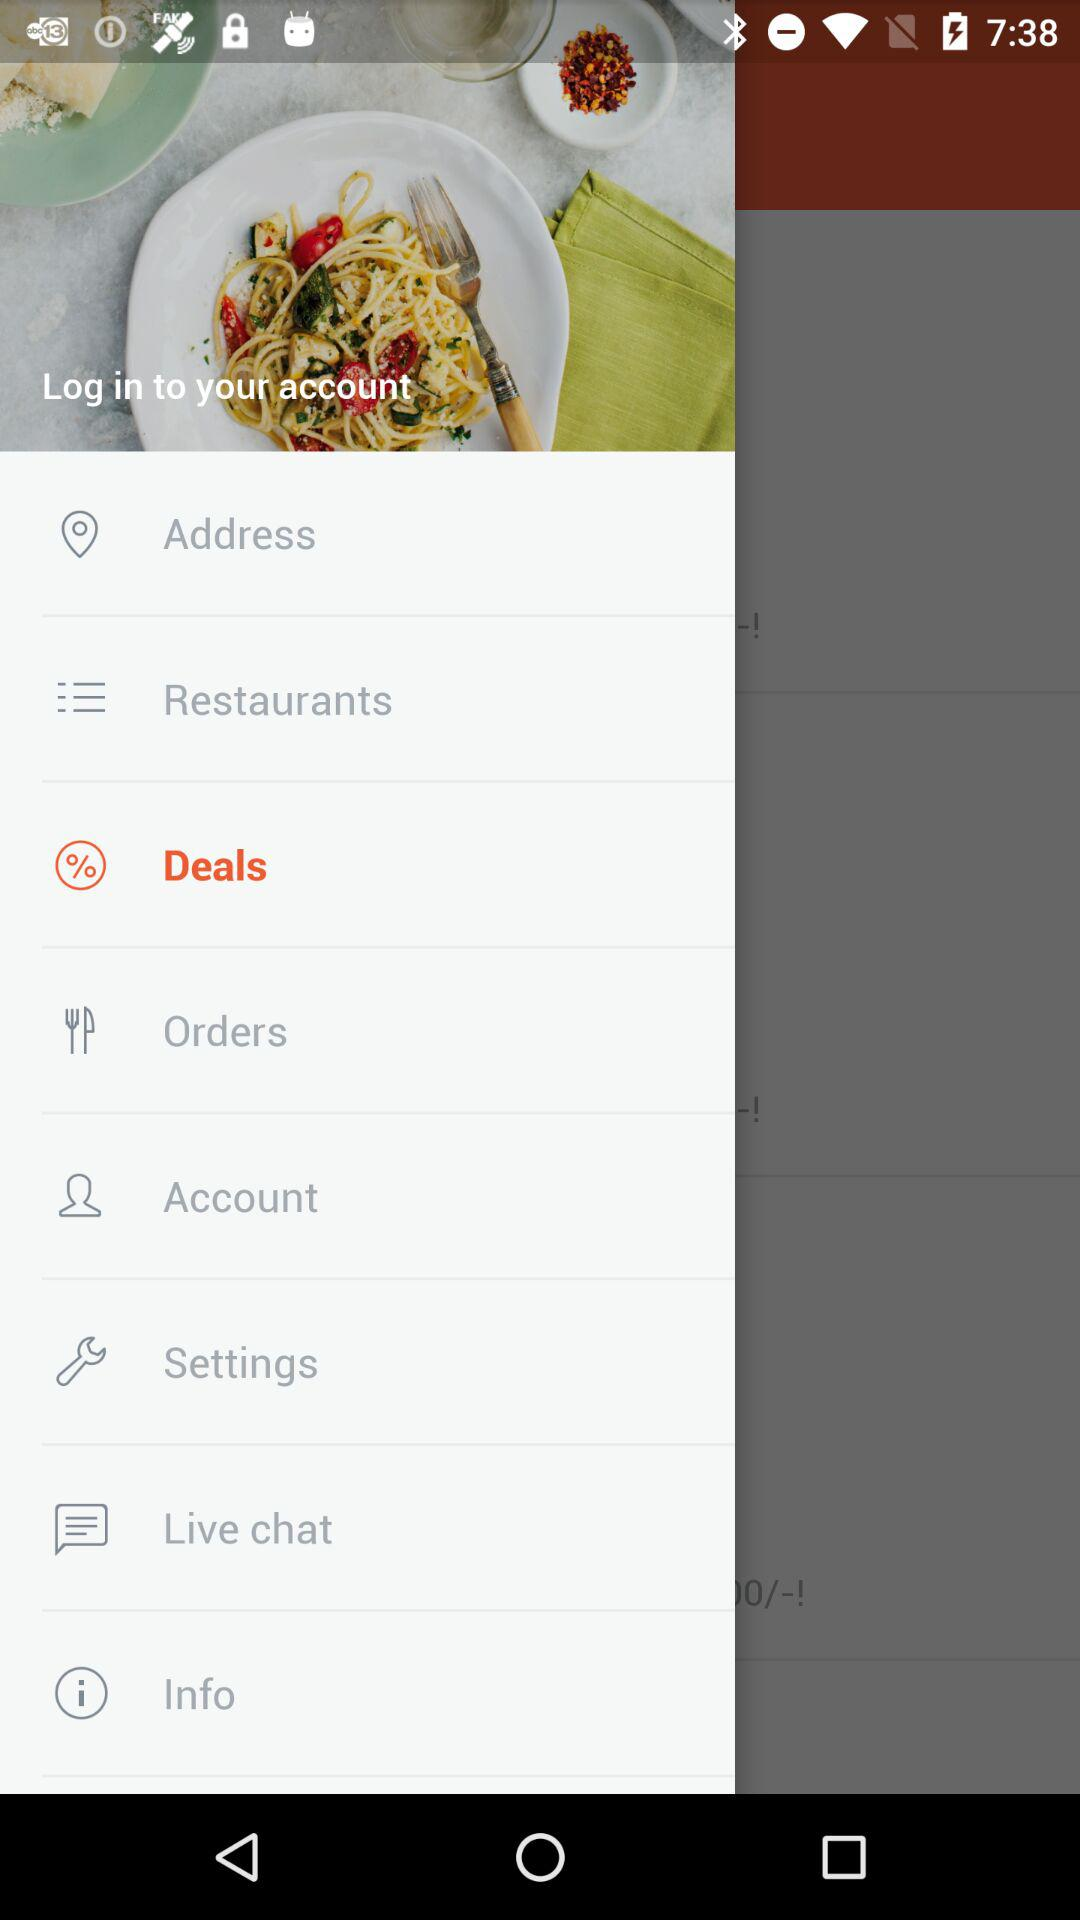Which item was selected? The selected item was "Deals". 